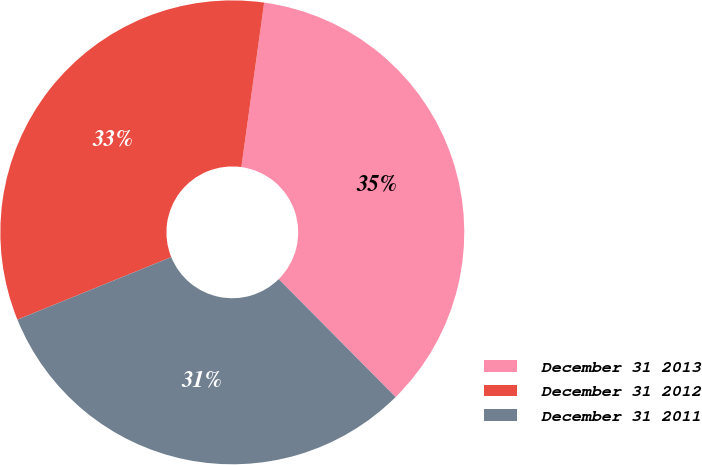Convert chart. <chart><loc_0><loc_0><loc_500><loc_500><pie_chart><fcel>December 31 2013<fcel>December 31 2012<fcel>December 31 2011<nl><fcel>35.38%<fcel>33.34%<fcel>31.29%<nl></chart> 